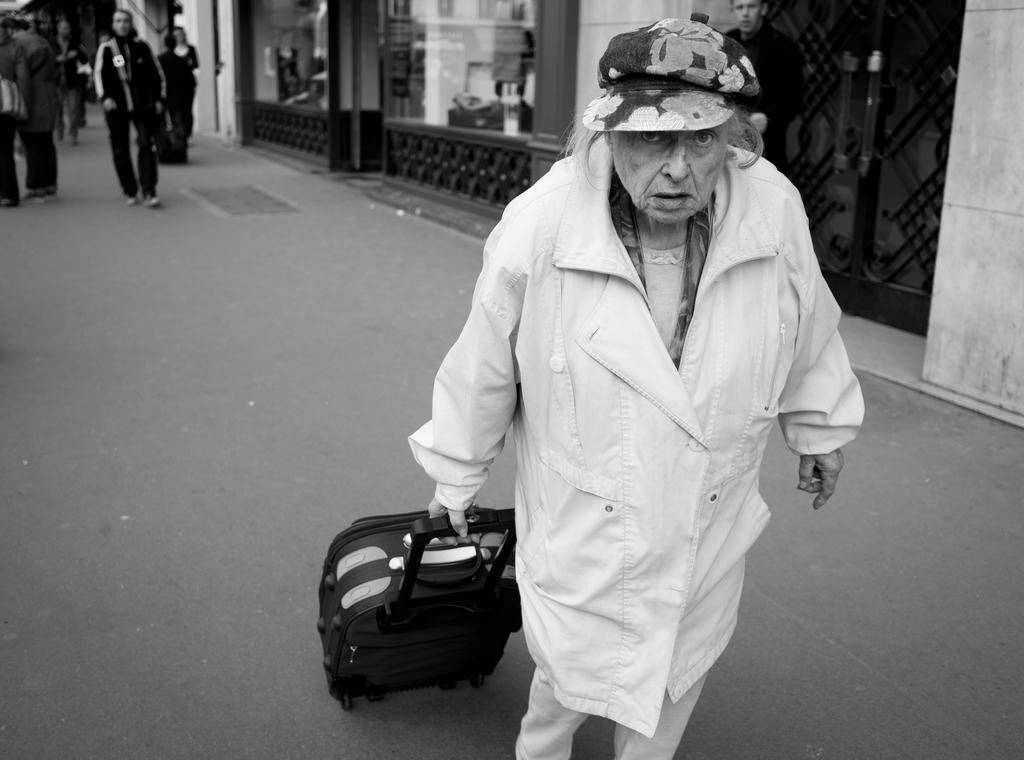Can you describe this image briefly? Black and white picture. Front this old women wore jacket and holding a luggage. Far few persons are walking, as there is a leg movement. In-front of this door a person is standing. Beside this woman there is a building with glass. 